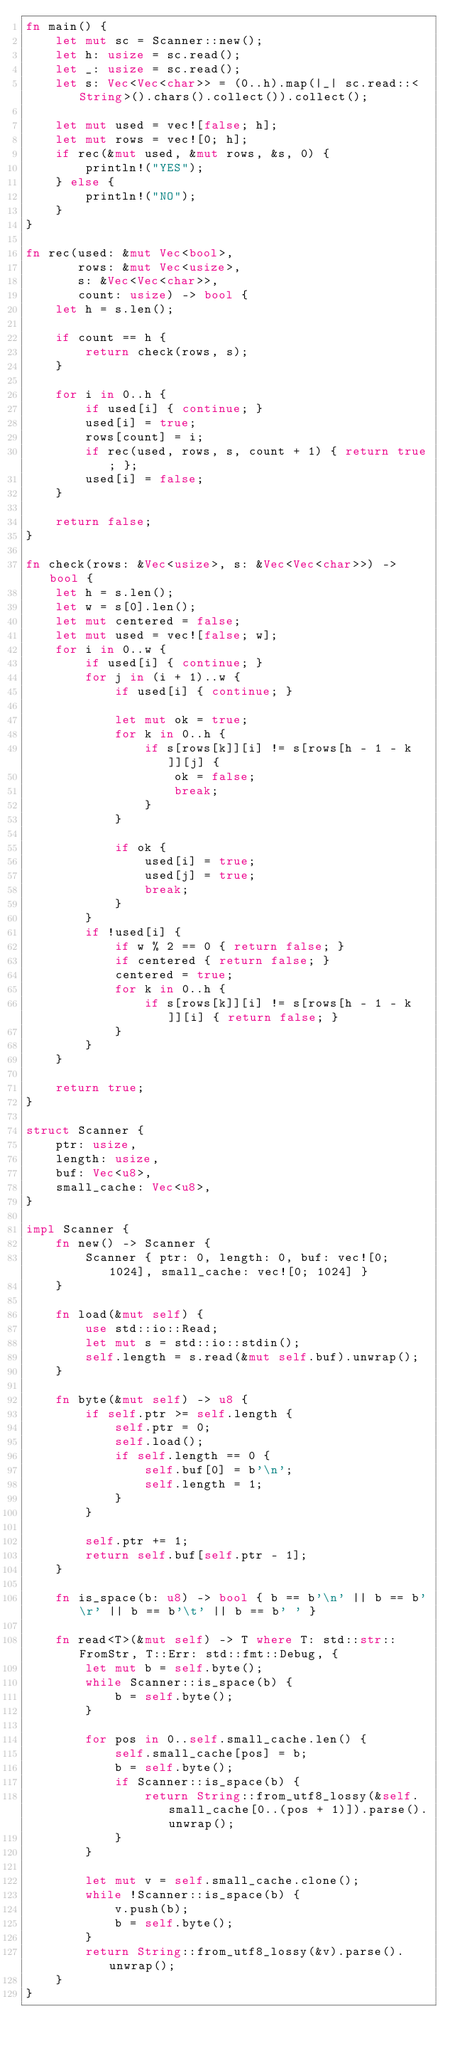Convert code to text. <code><loc_0><loc_0><loc_500><loc_500><_Rust_>fn main() {
    let mut sc = Scanner::new();
    let h: usize = sc.read();
    let _: usize = sc.read();
    let s: Vec<Vec<char>> = (0..h).map(|_| sc.read::<String>().chars().collect()).collect();

    let mut used = vec![false; h];
    let mut rows = vec![0; h];
    if rec(&mut used, &mut rows, &s, 0) {
        println!("YES");
    } else {
        println!("NO");
    }
}

fn rec(used: &mut Vec<bool>,
       rows: &mut Vec<usize>,
       s: &Vec<Vec<char>>,
       count: usize) -> bool {
    let h = s.len();

    if count == h {
        return check(rows, s);
    }

    for i in 0..h {
        if used[i] { continue; }
        used[i] = true;
        rows[count] = i;
        if rec(used, rows, s, count + 1) { return true; };
        used[i] = false;
    }

    return false;
}

fn check(rows: &Vec<usize>, s: &Vec<Vec<char>>) -> bool {
    let h = s.len();
    let w = s[0].len();
    let mut centered = false;
    let mut used = vec![false; w];
    for i in 0..w {
        if used[i] { continue; }
        for j in (i + 1)..w {
            if used[i] { continue; }

            let mut ok = true;
            for k in 0..h {
                if s[rows[k]][i] != s[rows[h - 1 - k]][j] {
                    ok = false;
                    break;
                }
            }

            if ok {
                used[i] = true;
                used[j] = true;
                break;
            }
        }
        if !used[i] {
            if w % 2 == 0 { return false; }
            if centered { return false; }
            centered = true;
            for k in 0..h {
                if s[rows[k]][i] != s[rows[h - 1 - k]][i] { return false; }
            }
        }
    }

    return true;
}

struct Scanner {
    ptr: usize,
    length: usize,
    buf: Vec<u8>,
    small_cache: Vec<u8>,
}

impl Scanner {
    fn new() -> Scanner {
        Scanner { ptr: 0, length: 0, buf: vec![0; 1024], small_cache: vec![0; 1024] }
    }

    fn load(&mut self) {
        use std::io::Read;
        let mut s = std::io::stdin();
        self.length = s.read(&mut self.buf).unwrap();
    }

    fn byte(&mut self) -> u8 {
        if self.ptr >= self.length {
            self.ptr = 0;
            self.load();
            if self.length == 0 {
                self.buf[0] = b'\n';
                self.length = 1;
            }
        }

        self.ptr += 1;
        return self.buf[self.ptr - 1];
    }

    fn is_space(b: u8) -> bool { b == b'\n' || b == b'\r' || b == b'\t' || b == b' ' }

    fn read<T>(&mut self) -> T where T: std::str::FromStr, T::Err: std::fmt::Debug, {
        let mut b = self.byte();
        while Scanner::is_space(b) {
            b = self.byte();
        }

        for pos in 0..self.small_cache.len() {
            self.small_cache[pos] = b;
            b = self.byte();
            if Scanner::is_space(b) {
                return String::from_utf8_lossy(&self.small_cache[0..(pos + 1)]).parse().unwrap();
            }
        }

        let mut v = self.small_cache.clone();
        while !Scanner::is_space(b) {
            v.push(b);
            b = self.byte();
        }
        return String::from_utf8_lossy(&v).parse().unwrap();
    }
}

</code> 